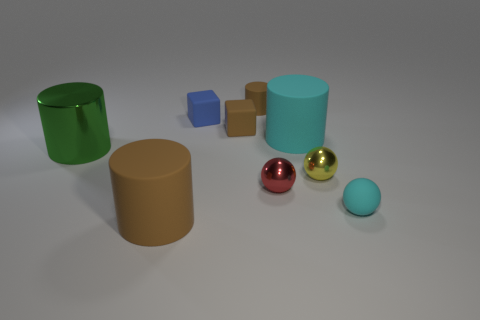What color is the small matte cylinder?
Ensure brevity in your answer.  Brown. What number of objects are either tiny brown blocks or red balls?
Offer a very short reply. 2. The brown rubber object that is right of the small brown matte object in front of the small brown cylinder is what shape?
Make the answer very short. Cylinder. What number of other things are made of the same material as the cyan sphere?
Provide a succinct answer. 5. Is the material of the red ball the same as the brown cylinder in front of the big cyan cylinder?
Your answer should be very brief. No. What number of things are big metallic things that are behind the small cyan matte object or cylinders that are on the left side of the small red metal sphere?
Offer a very short reply. 3. What number of other objects are the same color as the tiny matte cylinder?
Make the answer very short. 2. Are there more red metallic things that are behind the small cyan thing than cyan cylinders that are in front of the red thing?
Offer a terse response. Yes. Is there any other thing that is the same size as the red metal object?
Offer a very short reply. Yes. What number of cubes are blue objects or big green shiny objects?
Offer a terse response. 1. 